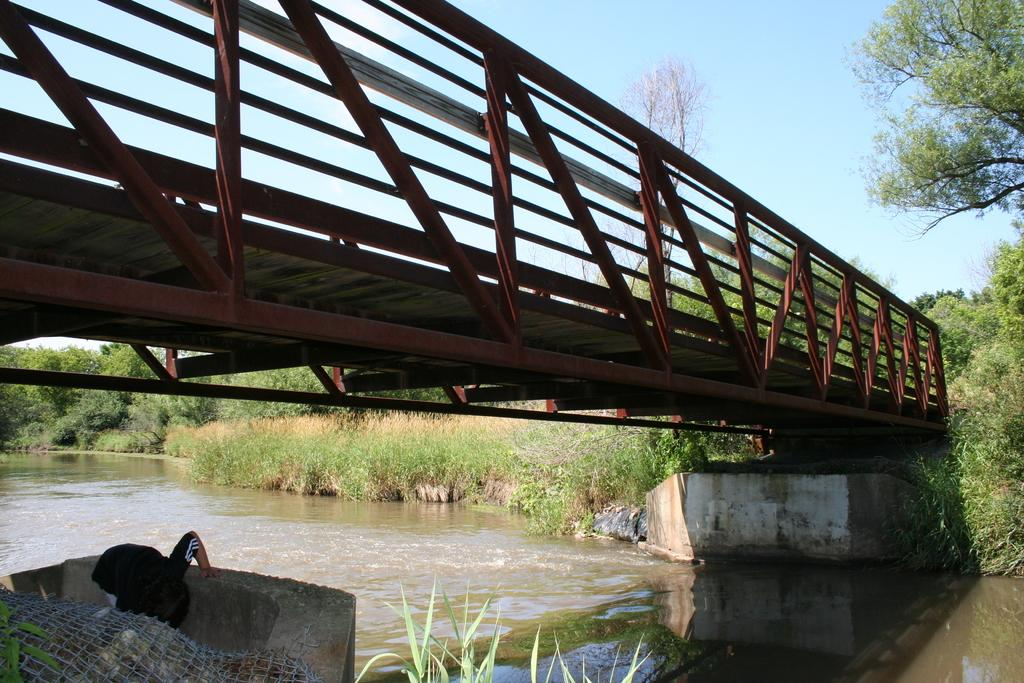What type of bridge is shown in the image? The image features an iron bridge. What can be seen below the bridge? There is water visible below the bridge. What is visible at the top of the image? The sky is visible at the top of the image. How many letters are written on the board in the image? There is no board present in the image, so it is not possible to determine the number of letters written on it. 